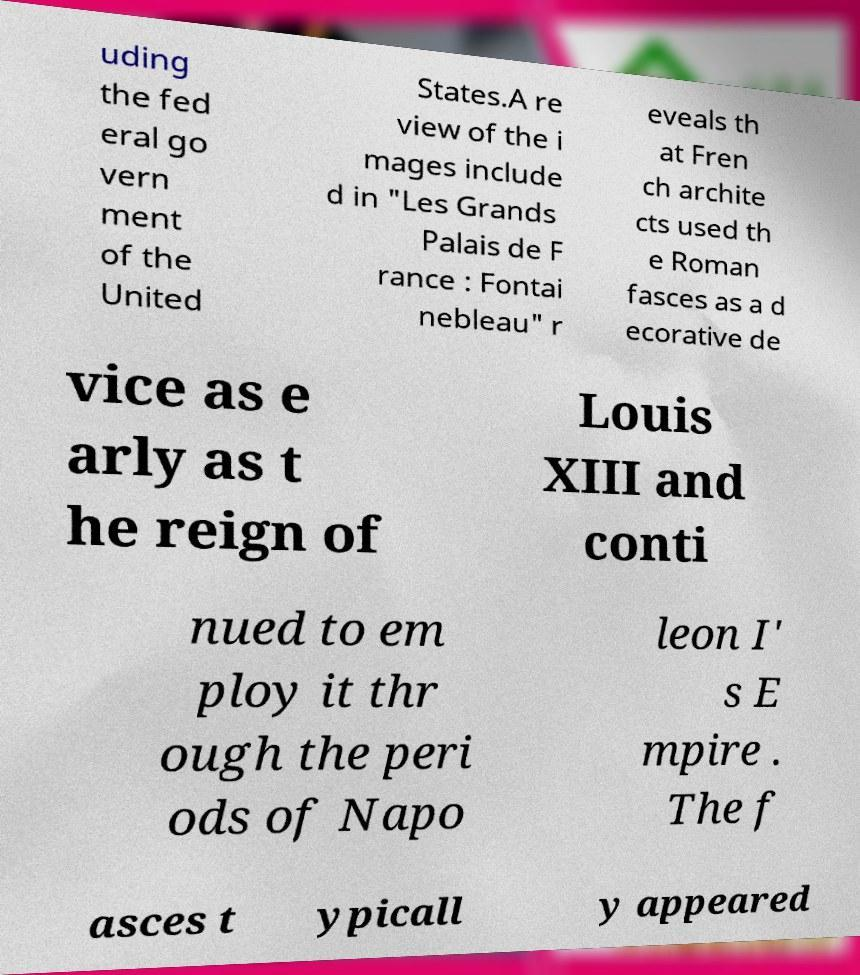Could you assist in decoding the text presented in this image and type it out clearly? uding the fed eral go vern ment of the United States.A re view of the i mages include d in "Les Grands Palais de F rance : Fontai nebleau" r eveals th at Fren ch archite cts used th e Roman fasces as a d ecorative de vice as e arly as t he reign of Louis XIII and conti nued to em ploy it thr ough the peri ods of Napo leon I' s E mpire . The f asces t ypicall y appeared 